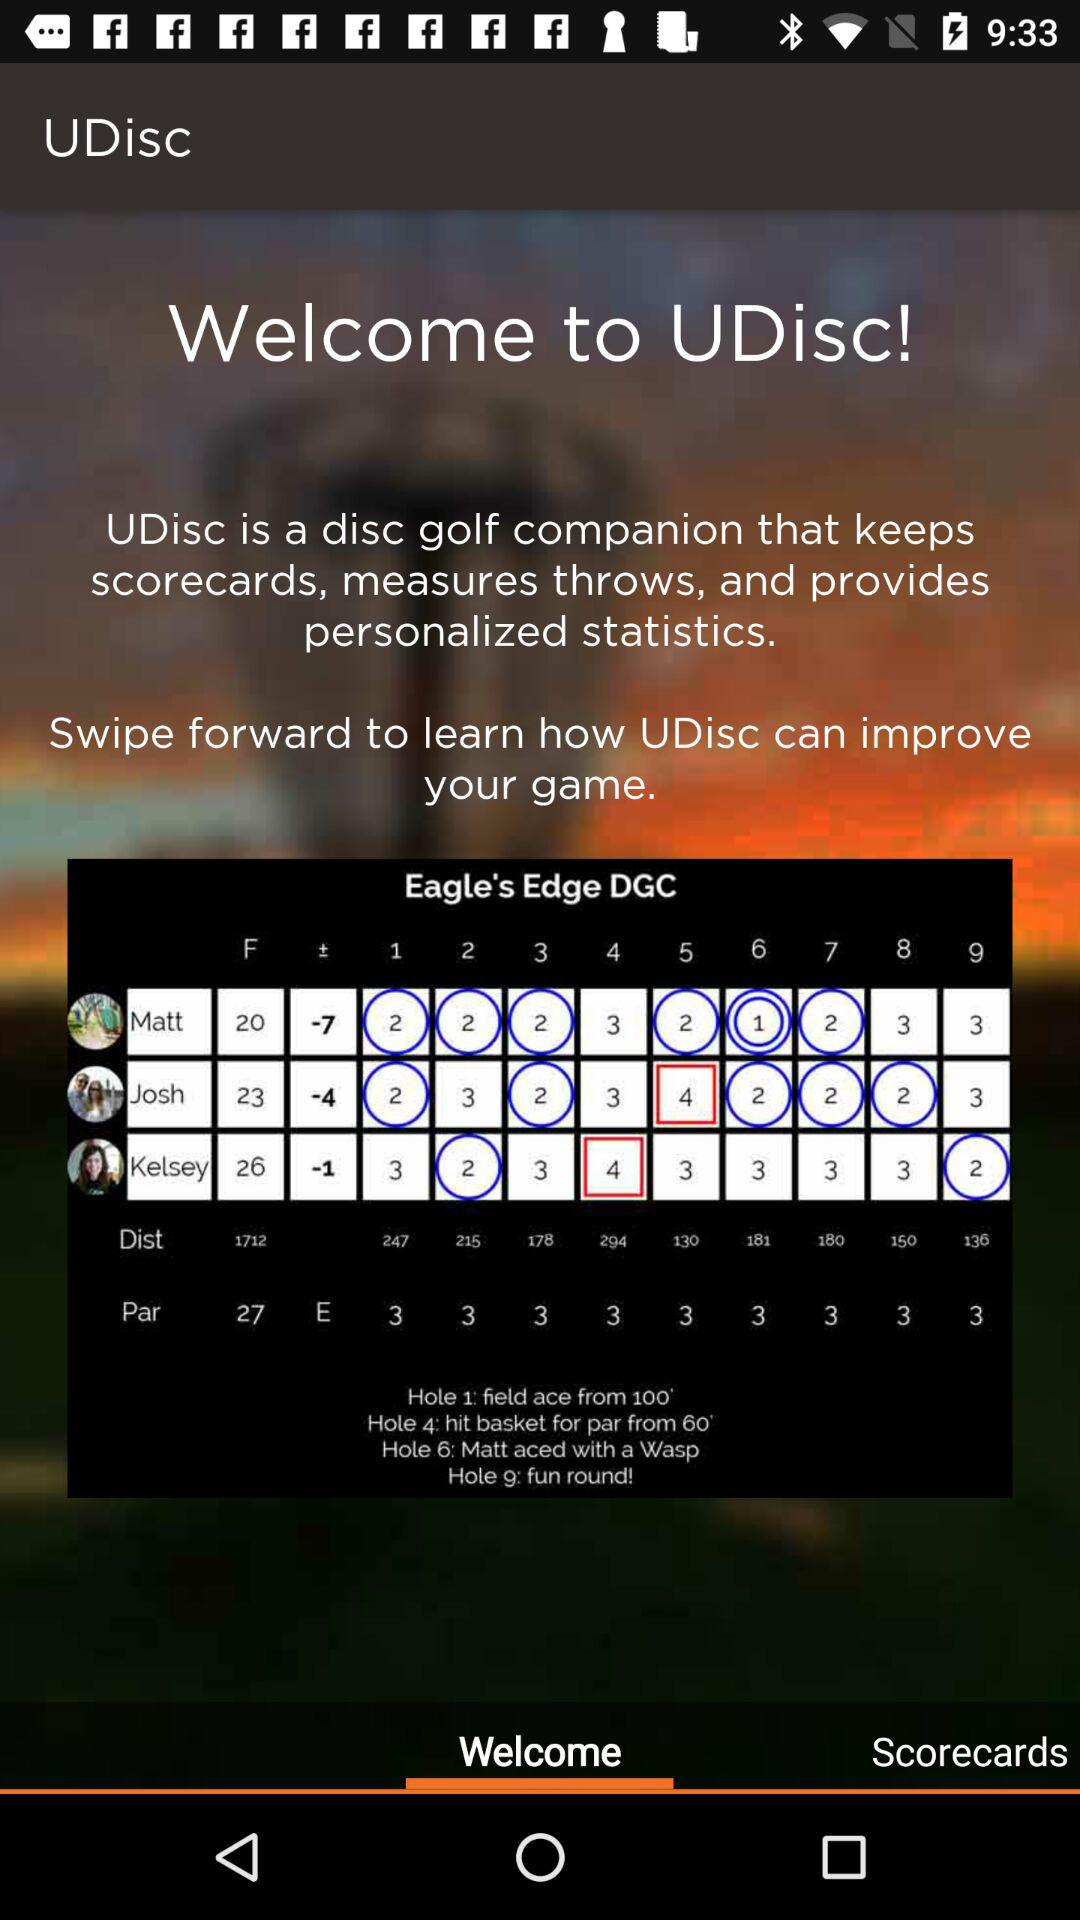What is the app name? The app name is "UDisc". 